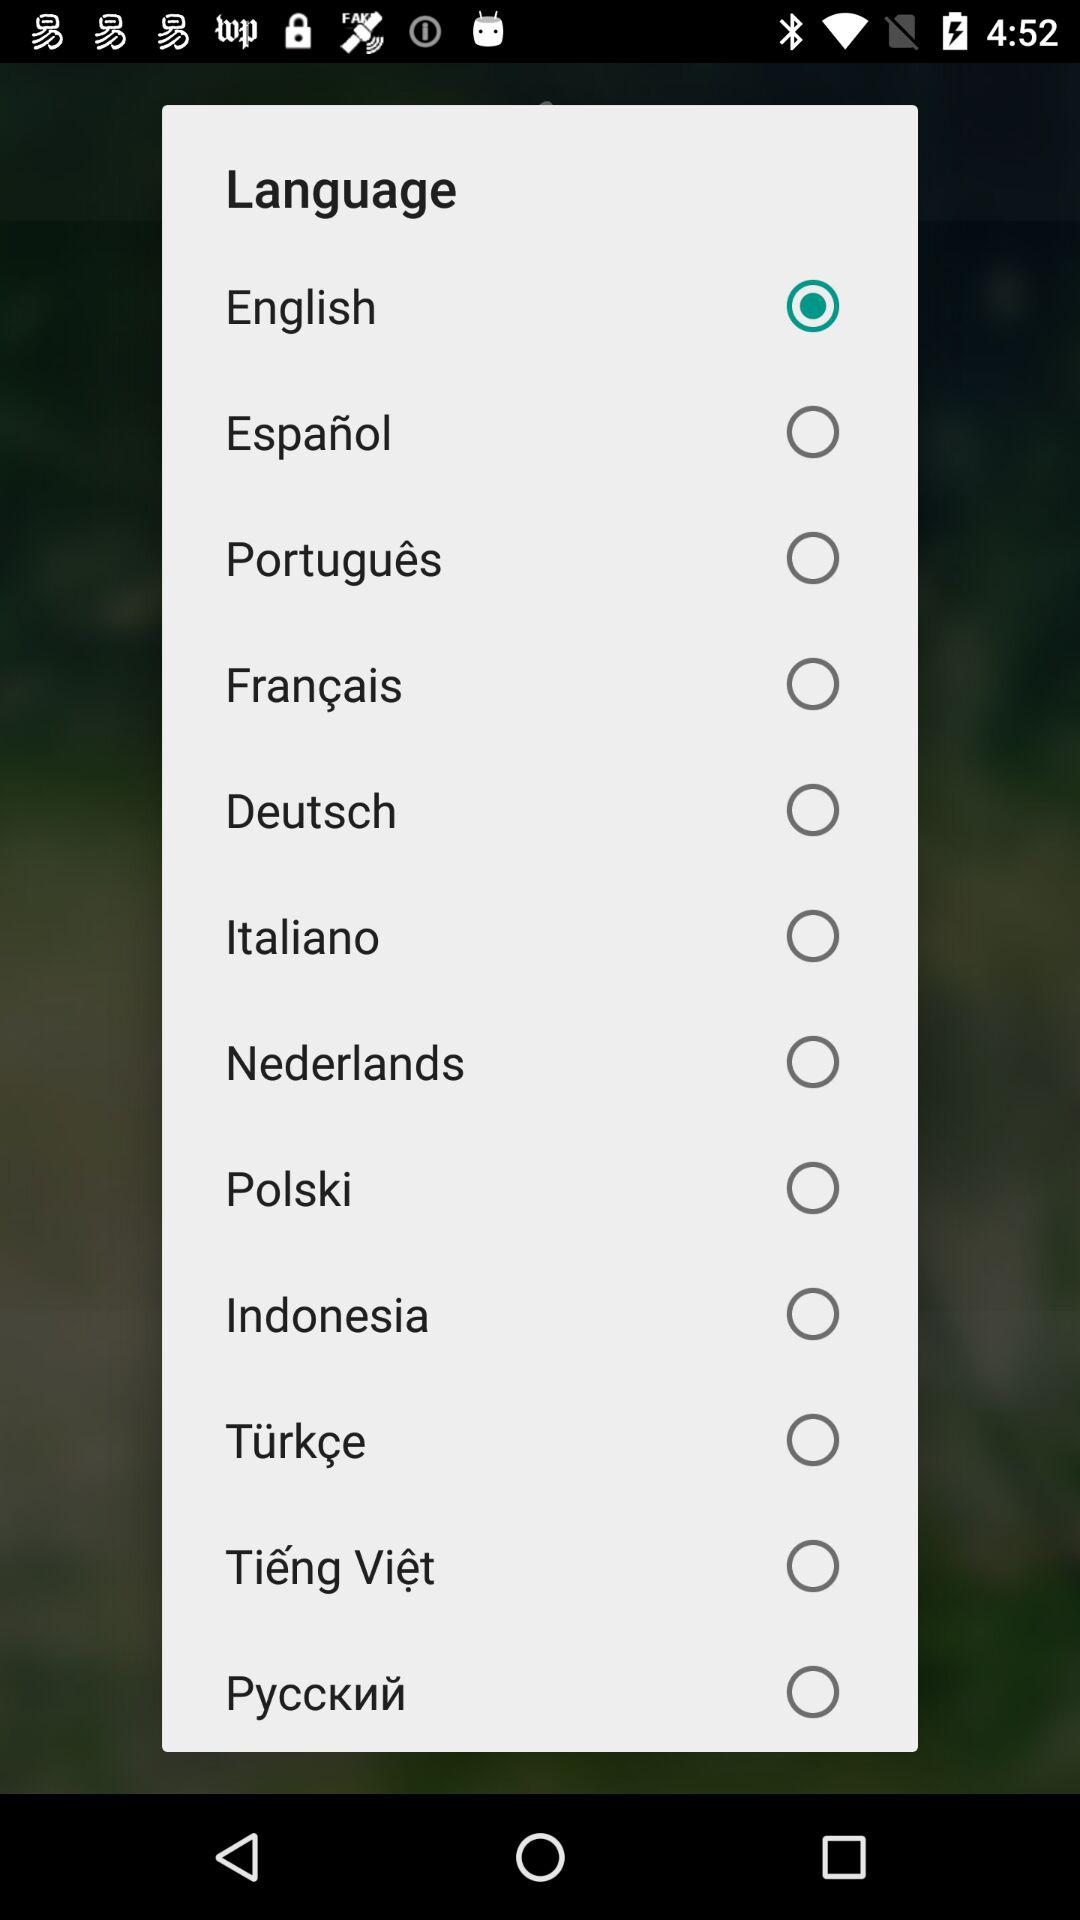What is the selected language? The selected language is English. 